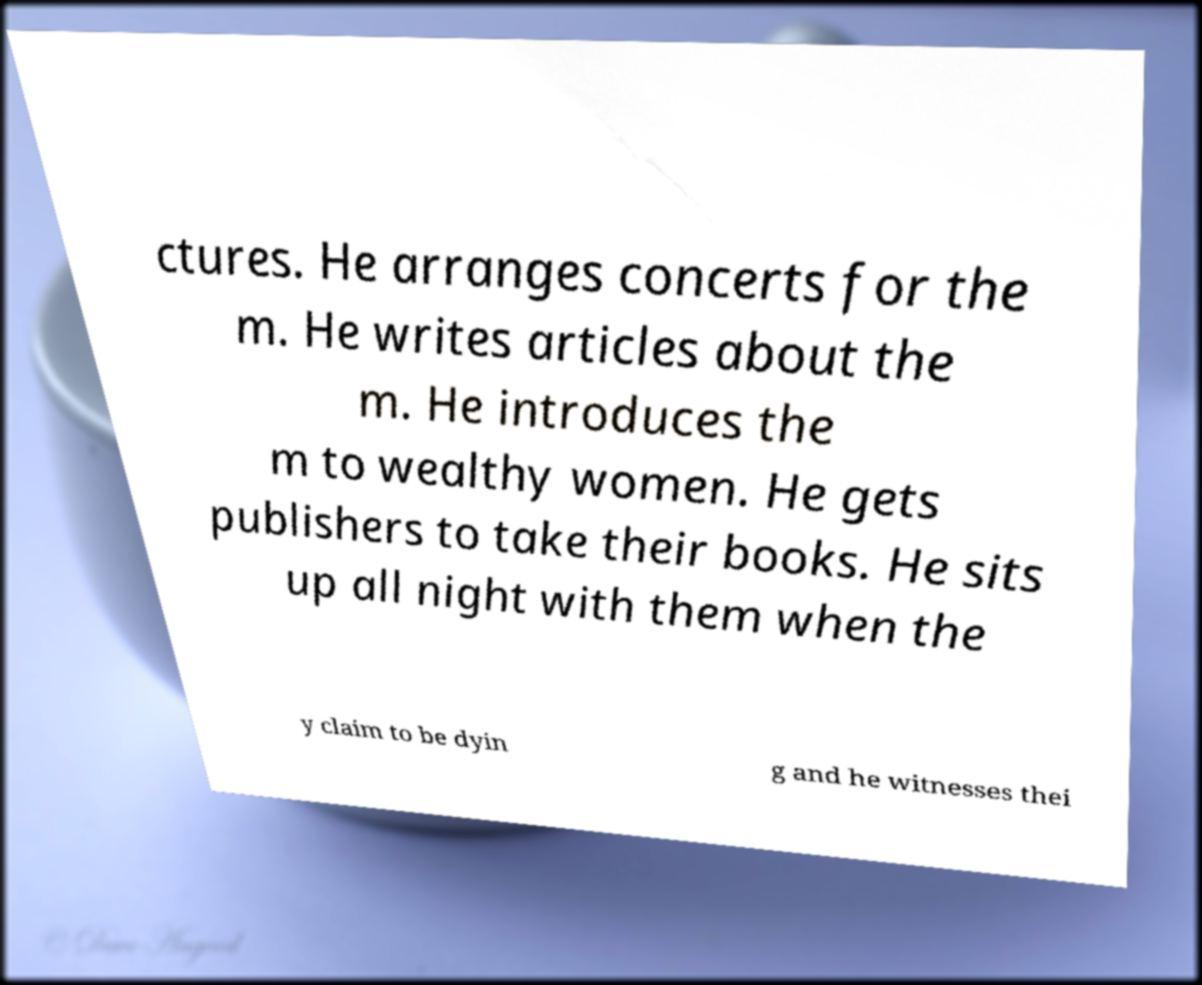There's text embedded in this image that I need extracted. Can you transcribe it verbatim? ctures. He arranges concerts for the m. He writes articles about the m. He introduces the m to wealthy women. He gets publishers to take their books. He sits up all night with them when the y claim to be dyin g and he witnesses thei 